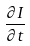Convert formula to latex. <formula><loc_0><loc_0><loc_500><loc_500>\frac { \partial I } { \partial t }</formula> 